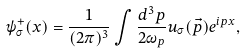Convert formula to latex. <formula><loc_0><loc_0><loc_500><loc_500>\psi _ { \sigma } ^ { + } ( x ) = \frac { 1 } { ( 2 \pi ) ^ { 3 } } \int \frac { d ^ { 3 } p } { 2 \omega _ { p } } u _ { \sigma } ( \vec { p } ) e ^ { i p x } ,</formula> 